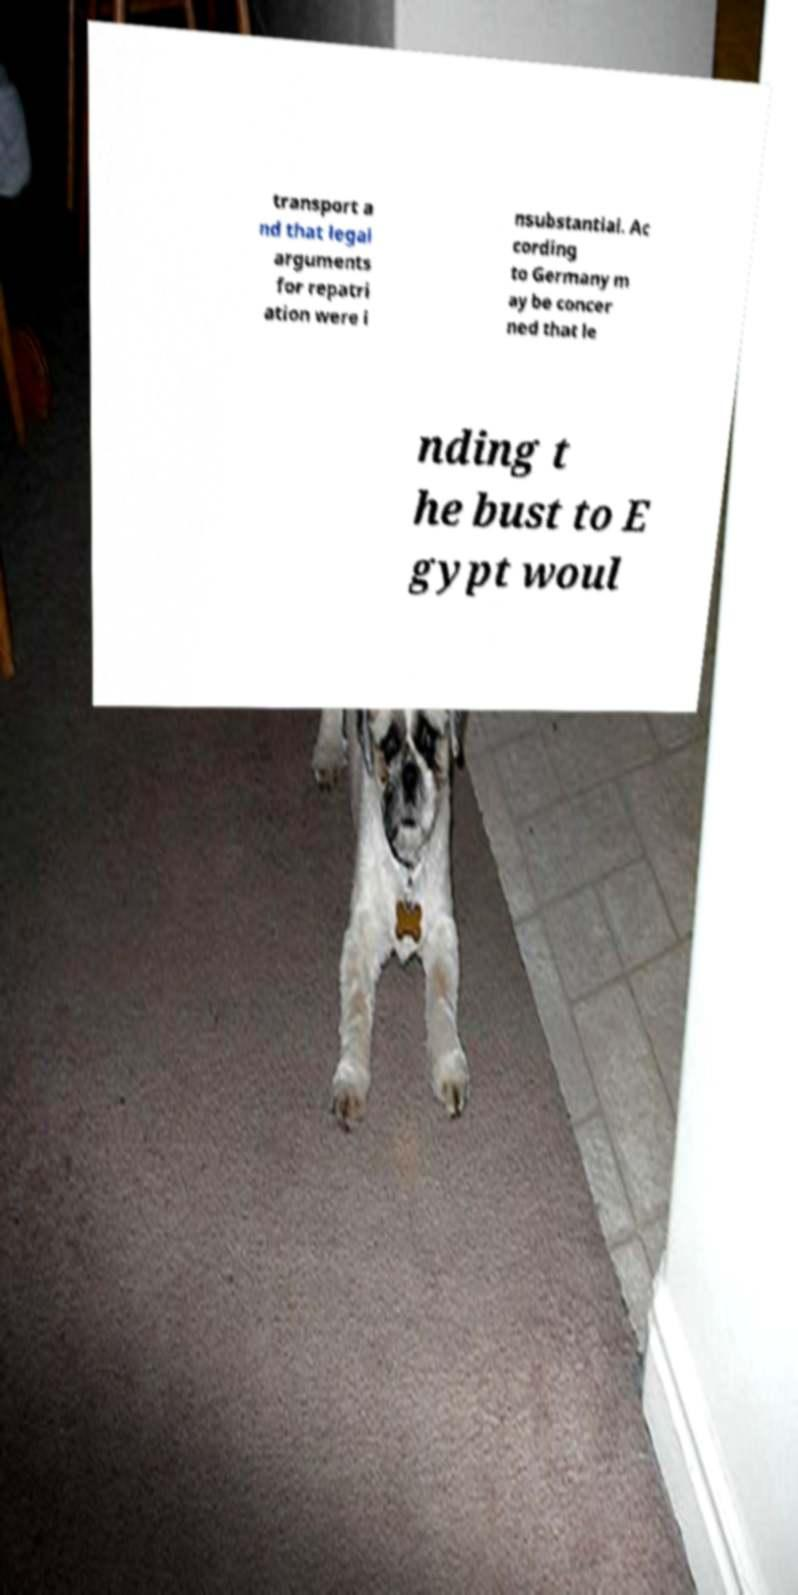What messages or text are displayed in this image? I need them in a readable, typed format. transport a nd that legal arguments for repatri ation were i nsubstantial. Ac cording to Germany m ay be concer ned that le nding t he bust to E gypt woul 